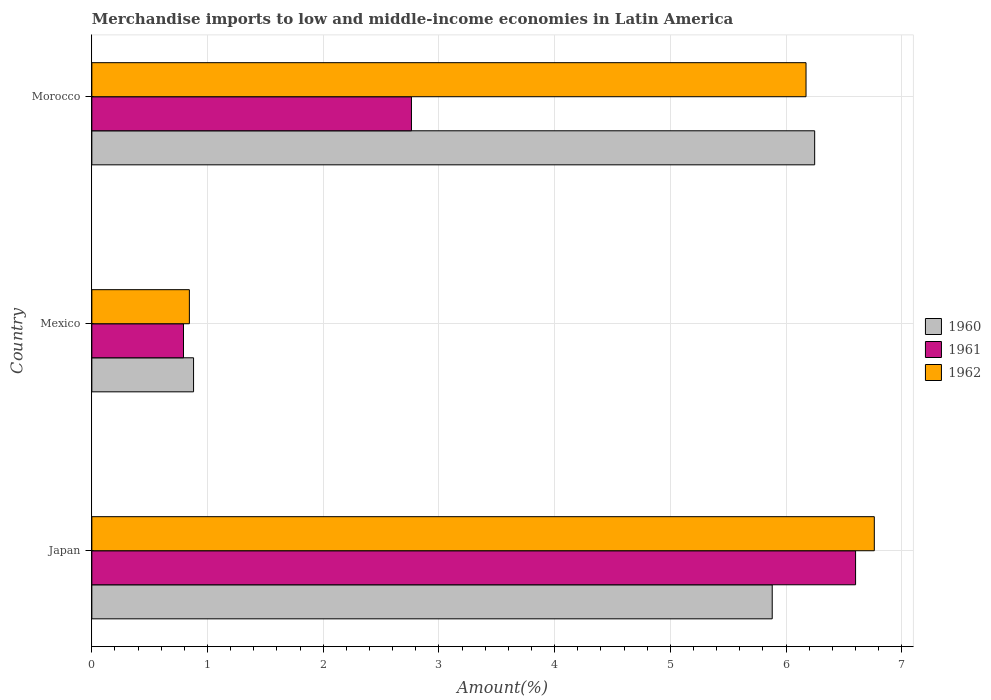How many groups of bars are there?
Offer a very short reply. 3. Are the number of bars per tick equal to the number of legend labels?
Keep it short and to the point. Yes. Are the number of bars on each tick of the Y-axis equal?
Ensure brevity in your answer.  Yes. What is the label of the 3rd group of bars from the top?
Your answer should be compact. Japan. What is the percentage of amount earned from merchandise imports in 1962 in Mexico?
Give a very brief answer. 0.84. Across all countries, what is the maximum percentage of amount earned from merchandise imports in 1960?
Provide a short and direct response. 6.25. Across all countries, what is the minimum percentage of amount earned from merchandise imports in 1962?
Keep it short and to the point. 0.84. What is the total percentage of amount earned from merchandise imports in 1962 in the graph?
Ensure brevity in your answer.  13.78. What is the difference between the percentage of amount earned from merchandise imports in 1960 in Japan and that in Mexico?
Offer a very short reply. 5. What is the difference between the percentage of amount earned from merchandise imports in 1960 in Morocco and the percentage of amount earned from merchandise imports in 1961 in Mexico?
Offer a very short reply. 5.45. What is the average percentage of amount earned from merchandise imports in 1961 per country?
Your response must be concise. 3.38. What is the difference between the percentage of amount earned from merchandise imports in 1960 and percentage of amount earned from merchandise imports in 1961 in Japan?
Keep it short and to the point. -0.72. What is the ratio of the percentage of amount earned from merchandise imports in 1960 in Japan to that in Mexico?
Your response must be concise. 6.69. Is the percentage of amount earned from merchandise imports in 1961 in Japan less than that in Mexico?
Provide a succinct answer. No. Is the difference between the percentage of amount earned from merchandise imports in 1960 in Japan and Mexico greater than the difference between the percentage of amount earned from merchandise imports in 1961 in Japan and Mexico?
Provide a short and direct response. No. What is the difference between the highest and the second highest percentage of amount earned from merchandise imports in 1961?
Your answer should be compact. 3.84. What is the difference between the highest and the lowest percentage of amount earned from merchandise imports in 1961?
Ensure brevity in your answer.  5.81. In how many countries, is the percentage of amount earned from merchandise imports in 1960 greater than the average percentage of amount earned from merchandise imports in 1960 taken over all countries?
Your response must be concise. 2. Is the sum of the percentage of amount earned from merchandise imports in 1961 in Japan and Morocco greater than the maximum percentage of amount earned from merchandise imports in 1960 across all countries?
Give a very brief answer. Yes. What does the 3rd bar from the top in Japan represents?
Provide a succinct answer. 1960. What does the 1st bar from the bottom in Japan represents?
Your answer should be very brief. 1960. How many bars are there?
Give a very brief answer. 9. Are all the bars in the graph horizontal?
Make the answer very short. Yes. How many countries are there in the graph?
Your answer should be compact. 3. What is the difference between two consecutive major ticks on the X-axis?
Your answer should be very brief. 1. Where does the legend appear in the graph?
Offer a very short reply. Center right. How many legend labels are there?
Your answer should be compact. 3. How are the legend labels stacked?
Give a very brief answer. Vertical. What is the title of the graph?
Your response must be concise. Merchandise imports to low and middle-income economies in Latin America. Does "1994" appear as one of the legend labels in the graph?
Give a very brief answer. No. What is the label or title of the X-axis?
Your response must be concise. Amount(%). What is the Amount(%) in 1960 in Japan?
Make the answer very short. 5.88. What is the Amount(%) in 1961 in Japan?
Your answer should be very brief. 6.6. What is the Amount(%) of 1962 in Japan?
Your response must be concise. 6.76. What is the Amount(%) of 1960 in Mexico?
Make the answer very short. 0.88. What is the Amount(%) of 1961 in Mexico?
Provide a succinct answer. 0.79. What is the Amount(%) of 1962 in Mexico?
Your answer should be compact. 0.84. What is the Amount(%) in 1960 in Morocco?
Give a very brief answer. 6.25. What is the Amount(%) in 1961 in Morocco?
Give a very brief answer. 2.76. What is the Amount(%) in 1962 in Morocco?
Ensure brevity in your answer.  6.17. Across all countries, what is the maximum Amount(%) of 1960?
Your response must be concise. 6.25. Across all countries, what is the maximum Amount(%) of 1961?
Provide a short and direct response. 6.6. Across all countries, what is the maximum Amount(%) in 1962?
Ensure brevity in your answer.  6.76. Across all countries, what is the minimum Amount(%) in 1960?
Ensure brevity in your answer.  0.88. Across all countries, what is the minimum Amount(%) of 1961?
Ensure brevity in your answer.  0.79. Across all countries, what is the minimum Amount(%) of 1962?
Offer a very short reply. 0.84. What is the total Amount(%) in 1960 in the graph?
Give a very brief answer. 13.01. What is the total Amount(%) of 1961 in the graph?
Your answer should be compact. 10.15. What is the total Amount(%) of 1962 in the graph?
Your response must be concise. 13.78. What is the difference between the Amount(%) in 1960 in Japan and that in Mexico?
Provide a short and direct response. 5. What is the difference between the Amount(%) of 1961 in Japan and that in Mexico?
Give a very brief answer. 5.81. What is the difference between the Amount(%) in 1962 in Japan and that in Mexico?
Offer a terse response. 5.92. What is the difference between the Amount(%) in 1960 in Japan and that in Morocco?
Ensure brevity in your answer.  -0.37. What is the difference between the Amount(%) in 1961 in Japan and that in Morocco?
Offer a terse response. 3.84. What is the difference between the Amount(%) in 1962 in Japan and that in Morocco?
Your answer should be very brief. 0.59. What is the difference between the Amount(%) of 1960 in Mexico and that in Morocco?
Your answer should be compact. -5.37. What is the difference between the Amount(%) of 1961 in Mexico and that in Morocco?
Keep it short and to the point. -1.97. What is the difference between the Amount(%) in 1962 in Mexico and that in Morocco?
Your response must be concise. -5.33. What is the difference between the Amount(%) in 1960 in Japan and the Amount(%) in 1961 in Mexico?
Provide a short and direct response. 5.09. What is the difference between the Amount(%) in 1960 in Japan and the Amount(%) in 1962 in Mexico?
Your response must be concise. 5.04. What is the difference between the Amount(%) of 1961 in Japan and the Amount(%) of 1962 in Mexico?
Ensure brevity in your answer.  5.76. What is the difference between the Amount(%) in 1960 in Japan and the Amount(%) in 1961 in Morocco?
Give a very brief answer. 3.12. What is the difference between the Amount(%) in 1960 in Japan and the Amount(%) in 1962 in Morocco?
Offer a very short reply. -0.29. What is the difference between the Amount(%) of 1961 in Japan and the Amount(%) of 1962 in Morocco?
Offer a very short reply. 0.43. What is the difference between the Amount(%) in 1960 in Mexico and the Amount(%) in 1961 in Morocco?
Ensure brevity in your answer.  -1.88. What is the difference between the Amount(%) in 1960 in Mexico and the Amount(%) in 1962 in Morocco?
Keep it short and to the point. -5.29. What is the difference between the Amount(%) of 1961 in Mexico and the Amount(%) of 1962 in Morocco?
Offer a terse response. -5.38. What is the average Amount(%) of 1960 per country?
Provide a short and direct response. 4.34. What is the average Amount(%) of 1961 per country?
Offer a terse response. 3.38. What is the average Amount(%) in 1962 per country?
Keep it short and to the point. 4.59. What is the difference between the Amount(%) in 1960 and Amount(%) in 1961 in Japan?
Make the answer very short. -0.72. What is the difference between the Amount(%) in 1960 and Amount(%) in 1962 in Japan?
Offer a terse response. -0.88. What is the difference between the Amount(%) in 1961 and Amount(%) in 1962 in Japan?
Offer a terse response. -0.16. What is the difference between the Amount(%) of 1960 and Amount(%) of 1961 in Mexico?
Keep it short and to the point. 0.09. What is the difference between the Amount(%) of 1960 and Amount(%) of 1962 in Mexico?
Provide a succinct answer. 0.04. What is the difference between the Amount(%) in 1961 and Amount(%) in 1962 in Mexico?
Your answer should be very brief. -0.05. What is the difference between the Amount(%) of 1960 and Amount(%) of 1961 in Morocco?
Provide a short and direct response. 3.48. What is the difference between the Amount(%) in 1960 and Amount(%) in 1962 in Morocco?
Provide a succinct answer. 0.07. What is the difference between the Amount(%) in 1961 and Amount(%) in 1962 in Morocco?
Your answer should be very brief. -3.41. What is the ratio of the Amount(%) of 1960 in Japan to that in Mexico?
Offer a very short reply. 6.69. What is the ratio of the Amount(%) in 1961 in Japan to that in Mexico?
Offer a very short reply. 8.33. What is the ratio of the Amount(%) of 1962 in Japan to that in Mexico?
Your response must be concise. 8.02. What is the ratio of the Amount(%) in 1960 in Japan to that in Morocco?
Ensure brevity in your answer.  0.94. What is the ratio of the Amount(%) in 1961 in Japan to that in Morocco?
Make the answer very short. 2.39. What is the ratio of the Amount(%) in 1962 in Japan to that in Morocco?
Provide a short and direct response. 1.1. What is the ratio of the Amount(%) in 1960 in Mexico to that in Morocco?
Provide a succinct answer. 0.14. What is the ratio of the Amount(%) of 1961 in Mexico to that in Morocco?
Ensure brevity in your answer.  0.29. What is the ratio of the Amount(%) of 1962 in Mexico to that in Morocco?
Offer a terse response. 0.14. What is the difference between the highest and the second highest Amount(%) of 1960?
Ensure brevity in your answer.  0.37. What is the difference between the highest and the second highest Amount(%) in 1961?
Provide a succinct answer. 3.84. What is the difference between the highest and the second highest Amount(%) in 1962?
Your response must be concise. 0.59. What is the difference between the highest and the lowest Amount(%) in 1960?
Your response must be concise. 5.37. What is the difference between the highest and the lowest Amount(%) in 1961?
Keep it short and to the point. 5.81. What is the difference between the highest and the lowest Amount(%) of 1962?
Provide a short and direct response. 5.92. 